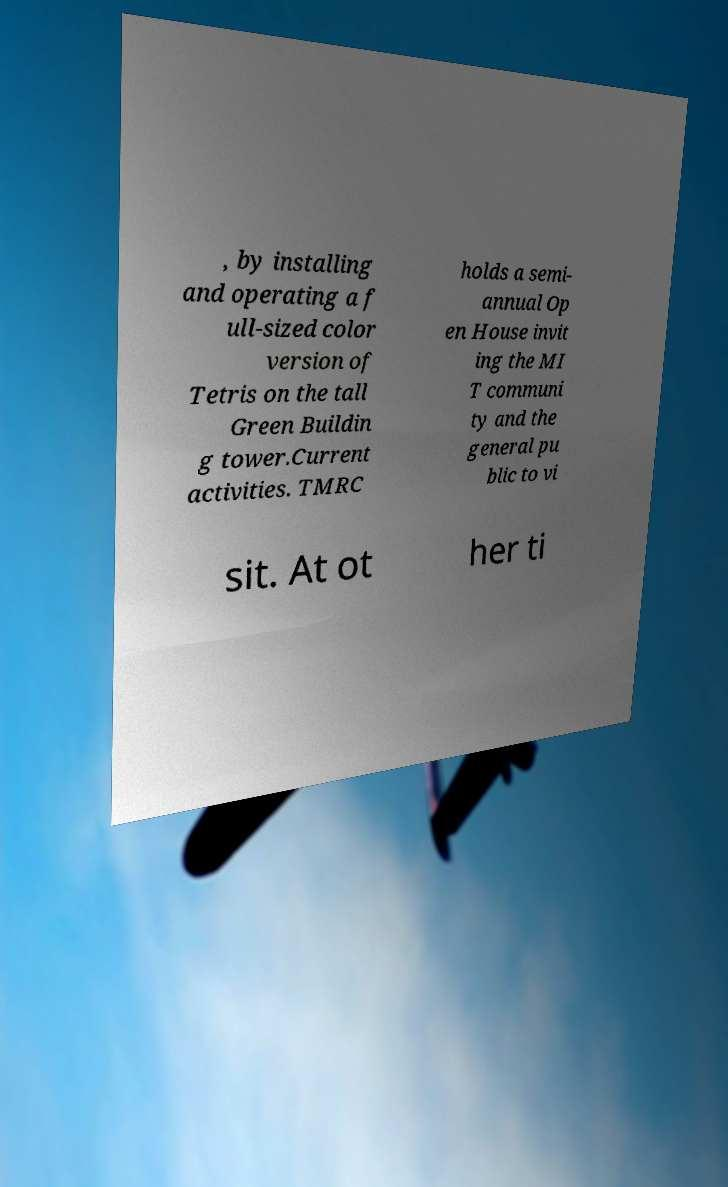For documentation purposes, I need the text within this image transcribed. Could you provide that? , by installing and operating a f ull-sized color version of Tetris on the tall Green Buildin g tower.Current activities. TMRC holds a semi- annual Op en House invit ing the MI T communi ty and the general pu blic to vi sit. At ot her ti 